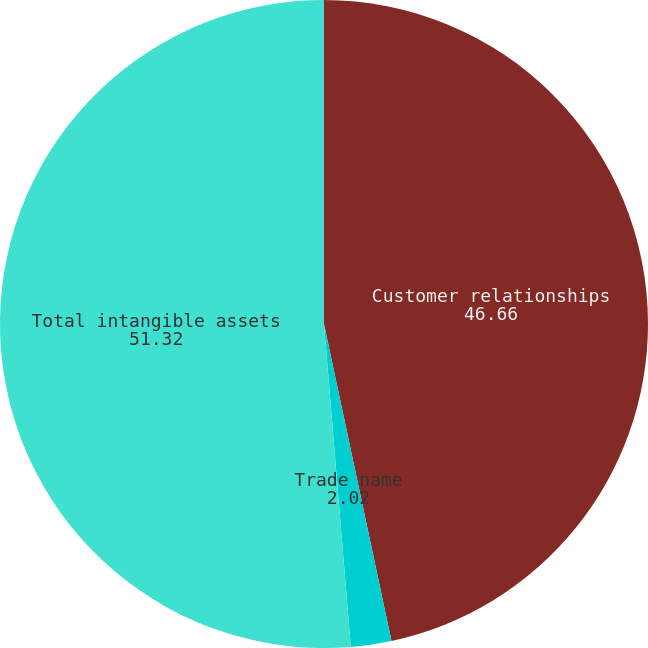Convert chart. <chart><loc_0><loc_0><loc_500><loc_500><pie_chart><fcel>Customer relationships<fcel>Trade name<fcel>Total intangible assets<nl><fcel>46.66%<fcel>2.02%<fcel>51.32%<nl></chart> 